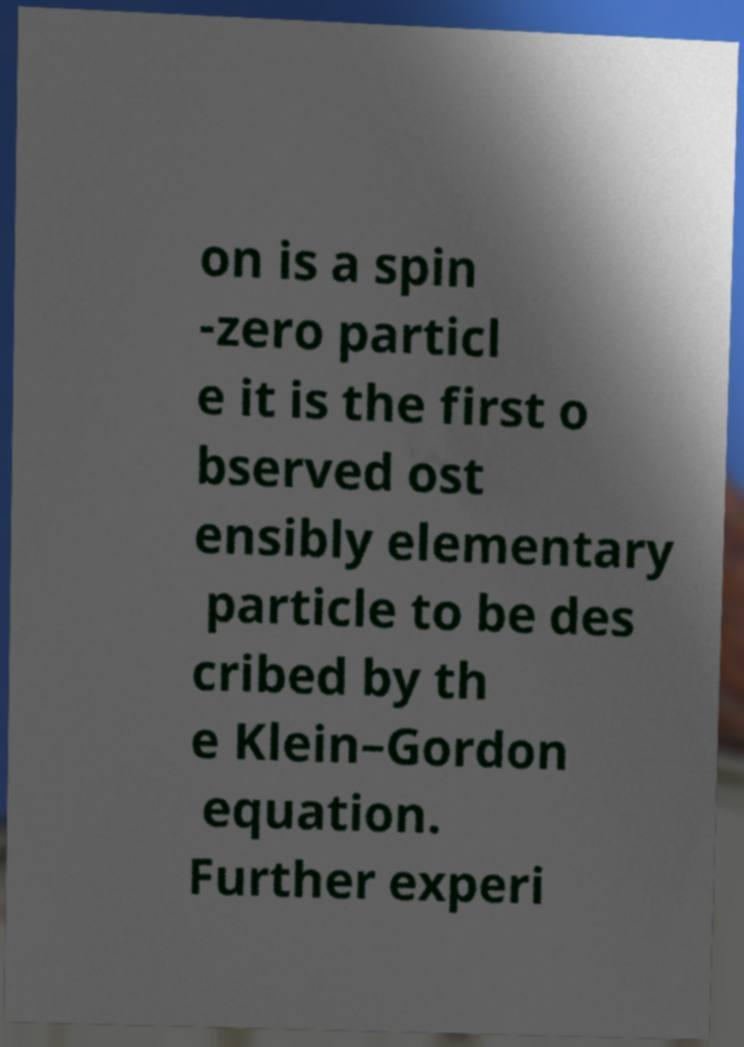Please identify and transcribe the text found in this image. on is a spin -zero particl e it is the first o bserved ost ensibly elementary particle to be des cribed by th e Klein–Gordon equation. Further experi 